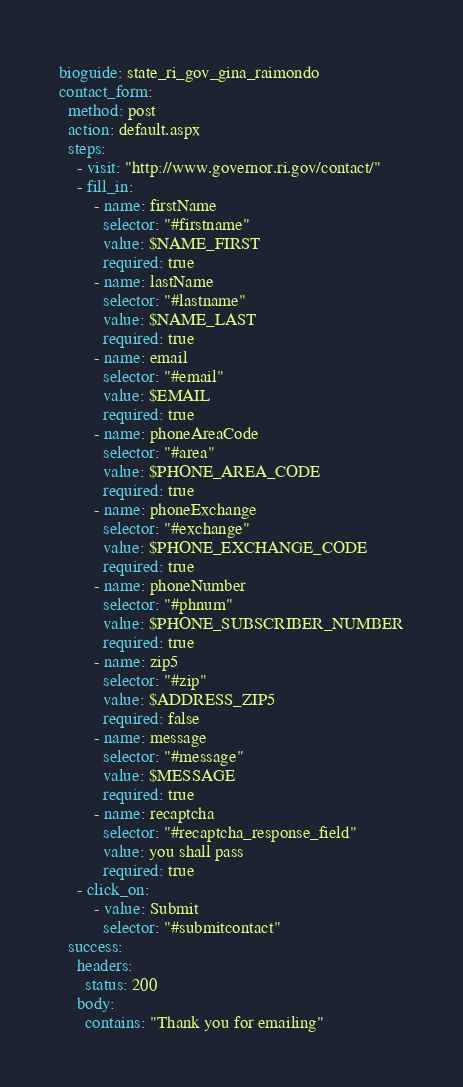Convert code to text. <code><loc_0><loc_0><loc_500><loc_500><_YAML_>bioguide: state_ri_gov_gina_raimondo
contact_form:
  method: post
  action: default.aspx
  steps:
    - visit: "http://www.governor.ri.gov/contact/"
    - fill_in:
        - name: firstName
          selector: "#firstname"
          value: $NAME_FIRST
          required: true
        - name: lastName
          selector: "#lastname"
          value: $NAME_LAST
          required: true
        - name: email
          selector: "#email"
          value: $EMAIL
          required: true
        - name: phoneAreaCode
          selector: "#area"
          value: $PHONE_AREA_CODE
          required: true
        - name: phoneExchange
          selector: "#exchange"
          value: $PHONE_EXCHANGE_CODE
          required: true
        - name: phoneNumber
          selector: "#phnum"
          value: $PHONE_SUBSCRIBER_NUMBER
          required: true
        - name: zip5
          selector: "#zip"
          value: $ADDRESS_ZIP5
          required: false
        - name: message
          selector: "#message"
          value: $MESSAGE
          required: true
        - name: recaptcha
          selector: "#recaptcha_response_field"
          value: you shall pass
          required: true
    - click_on:
        - value: Submit
          selector: "#submitcontact"
  success:
    headers:
      status: 200
    body:
      contains: "Thank you for emailing"
</code> 